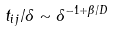<formula> <loc_0><loc_0><loc_500><loc_500>t _ { i j } / { \delta } \sim { \delta ^ { - 1 + \beta / D } }</formula> 